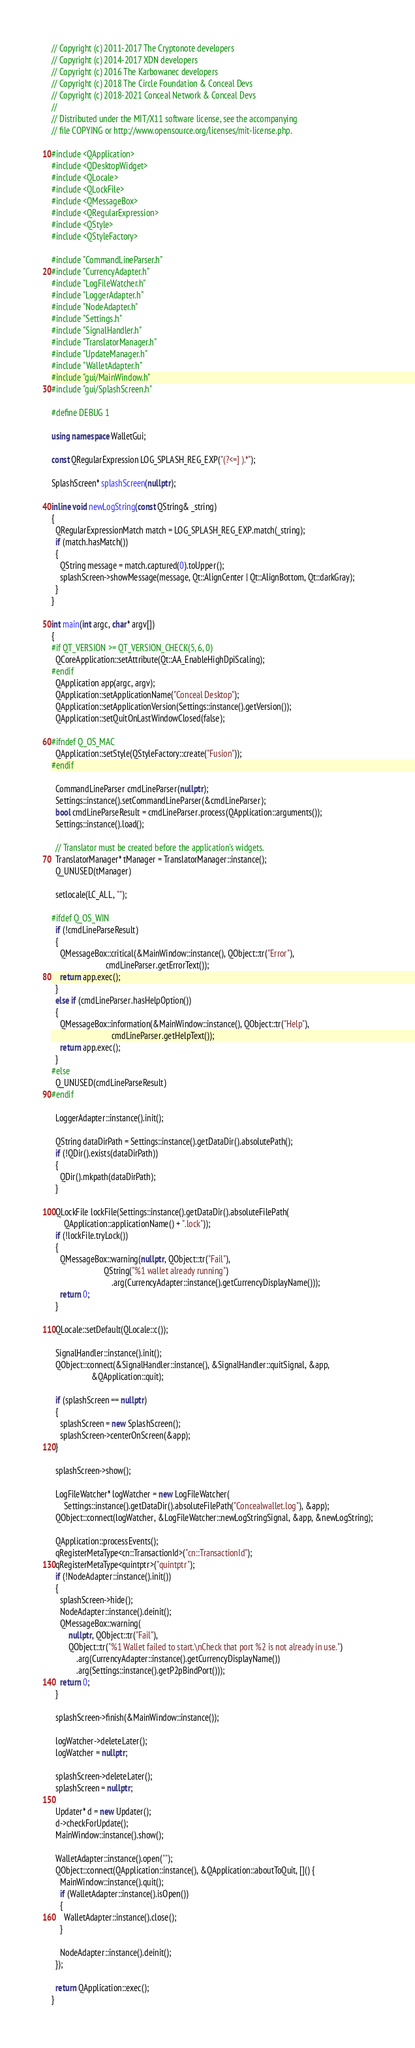<code> <loc_0><loc_0><loc_500><loc_500><_C++_>// Copyright (c) 2011-2017 The Cryptonote developers
// Copyright (c) 2014-2017 XDN developers
// Copyright (c) 2016 The Karbowanec developers
// Copyright (c) 2018 The Circle Foundation & Conceal Devs
// Copyright (c) 2018-2021 Conceal Network & Conceal Devs
//
// Distributed under the MIT/X11 software license, see the accompanying
// file COPYING or http://www.opensource.org/licenses/mit-license.php.

#include <QApplication>
#include <QDesktopWidget>
#include <QLocale>
#include <QLockFile>
#include <QMessageBox>
#include <QRegularExpression>
#include <QStyle>
#include <QStyleFactory>

#include "CommandLineParser.h"
#include "CurrencyAdapter.h"
#include "LogFileWatcher.h"
#include "LoggerAdapter.h"
#include "NodeAdapter.h"
#include "Settings.h"
#include "SignalHandler.h"
#include "TranslatorManager.h"
#include "UpdateManager.h"
#include "WalletAdapter.h"
#include "gui/MainWindow.h"
#include "gui/SplashScreen.h"

#define DEBUG 1

using namespace WalletGui;

const QRegularExpression LOG_SPLASH_REG_EXP("(?<=] ).*");

SplashScreen* splashScreen(nullptr);

inline void newLogString(const QString& _string)
{
  QRegularExpressionMatch match = LOG_SPLASH_REG_EXP.match(_string);
  if (match.hasMatch())
  {
    QString message = match.captured(0).toUpper();
    splashScreen->showMessage(message, Qt::AlignCenter | Qt::AlignBottom, Qt::darkGray);
  }
}

int main(int argc, char* argv[])
{
#if QT_VERSION >= QT_VERSION_CHECK(5, 6, 0)
  QCoreApplication::setAttribute(Qt::AA_EnableHighDpiScaling);
#endif
  QApplication app(argc, argv);
  QApplication::setApplicationName("Conceal Desktop");
  QApplication::setApplicationVersion(Settings::instance().getVersion());
  QApplication::setQuitOnLastWindowClosed(false);

#ifndef Q_OS_MAC
  QApplication::setStyle(QStyleFactory::create("Fusion"));
#endif

  CommandLineParser cmdLineParser(nullptr);
  Settings::instance().setCommandLineParser(&cmdLineParser);
  bool cmdLineParseResult = cmdLineParser.process(QApplication::arguments());
  Settings::instance().load();

  // Translator must be created before the application's widgets.
  TranslatorManager* tManager = TranslatorManager::instance();
  Q_UNUSED(tManager)

  setlocale(LC_ALL, "");

#ifdef Q_OS_WIN
  if (!cmdLineParseResult)
  {
    QMessageBox::critical(&MainWindow::instance(), QObject::tr("Error"),
                          cmdLineParser.getErrorText());
    return app.exec();
  }
  else if (cmdLineParser.hasHelpOption())
  {
    QMessageBox::information(&MainWindow::instance(), QObject::tr("Help"),
                             cmdLineParser.getHelpText());
    return app.exec();
  }
#else
  Q_UNUSED(cmdLineParseResult)
#endif

  LoggerAdapter::instance().init();

  QString dataDirPath = Settings::instance().getDataDir().absolutePath();
  if (!QDir().exists(dataDirPath))
  {
    QDir().mkpath(dataDirPath);
  }

  QLockFile lockFile(Settings::instance().getDataDir().absoluteFilePath(
      QApplication::applicationName() + ".lock"));
  if (!lockFile.tryLock())
  {
    QMessageBox::warning(nullptr, QObject::tr("Fail"),
                         QString("%1 wallet already running")
                             .arg(CurrencyAdapter::instance().getCurrencyDisplayName()));
    return 0;
  }

  QLocale::setDefault(QLocale::c());

  SignalHandler::instance().init();
  QObject::connect(&SignalHandler::instance(), &SignalHandler::quitSignal, &app,
                   &QApplication::quit);

  if (splashScreen == nullptr)
  {
    splashScreen = new SplashScreen();
    splashScreen->centerOnScreen(&app);
  }

  splashScreen->show();

  LogFileWatcher* logWatcher = new LogFileWatcher(
      Settings::instance().getDataDir().absoluteFilePath("Concealwallet.log"), &app);
  QObject::connect(logWatcher, &LogFileWatcher::newLogStringSignal, &app, &newLogString);

  QApplication::processEvents();
  qRegisterMetaType<cn::TransactionId>("cn::TransactionId");
  qRegisterMetaType<quintptr>("quintptr");
  if (!NodeAdapter::instance().init())
  {
    splashScreen->hide();
    NodeAdapter::instance().deinit();
    QMessageBox::warning(
        nullptr, QObject::tr("Fail"),
        QObject::tr("%1 Wallet failed to start.\nCheck that port %2 is not already in use.")
            .arg(CurrencyAdapter::instance().getCurrencyDisplayName())
            .arg(Settings::instance().getP2pBindPort()));
    return 0;
  }

  splashScreen->finish(&MainWindow::instance());

  logWatcher->deleteLater();
  logWatcher = nullptr;

  splashScreen->deleteLater();
  splashScreen = nullptr;

  Updater* d = new Updater();
  d->checkForUpdate();
  MainWindow::instance().show();

  WalletAdapter::instance().open("");
  QObject::connect(QApplication::instance(), &QApplication::aboutToQuit, []() {
    MainWindow::instance().quit();
    if (WalletAdapter::instance().isOpen())
    {
      WalletAdapter::instance().close();
    }

    NodeAdapter::instance().deinit();
  });

  return QApplication::exec();
}
</code> 